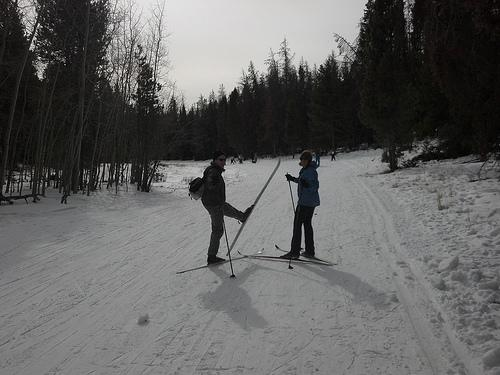Which sport-related activity is most prominent in the picture for a multi-choice VQA task? Snowboarding and skiing on a snow-covered slope with trees around. For a product advertisement task, highlight some elements of the image that might attract a potential customer interested in winter sports. Relish a thrilling winter sports experience amidst picturesque snowy slopes, tall trees, and clear ski paths. Enjoy skiing and snowboarding with your loved one surrounded by a breathtaking winter landscape. Provide a brief summary of the image contents for a visual entailment task. The image features a couple skiing on a snow-covered slope with tall trees around them, they are wearing snowboarding equipment and creating ski tracks in the snow. Describe the atmosphere of the image and what people are enjoying in it. A captivating winter ambiance with people relishing skiing and snowboarding on a snow-covered slope surrounded by a mix of leafy and bare trees, creating a memorable experience. What activity is the man in the foreground engaging in, as visible in the image? The man is skiing and holding one ski up in the air while wearing snowboarding equipment. Describe a captivating scene for a winter vacation advertisement using the image as inspiration. Escape to a winter wonderland and experience exhilarating skiing and snowboarding adventures on pristine, snow-covered slopes amid the breathtaking beauty of towering trees. Point out the specific details about the main subjects in the image for a referential expression grounding task. A man wearing sunglasses is holding one ski up in the air while a woman in a blue coat looks back. Both individuals are wearing snowboarding equipment and are surrounded by trees and ski tracks. Identify the main subjects in the image that could be used for a visual entailment task. A man holding a ski in the air and a woman in a blue coat on a snow-covered ski slope surrounded by tall trees. What is the most notable action involving a woman in the image? The woman, wearing a blue coat and sunglasses, is skiing while looking back, surrounded by snow and trees. What key feature can be used to advertise a winter holiday resort based on the image? People enjoying skiing and snowboarding on a picturesque snow-covered slope surrounded by tall leafy and bare trees, a perfect winter holiday experience. 